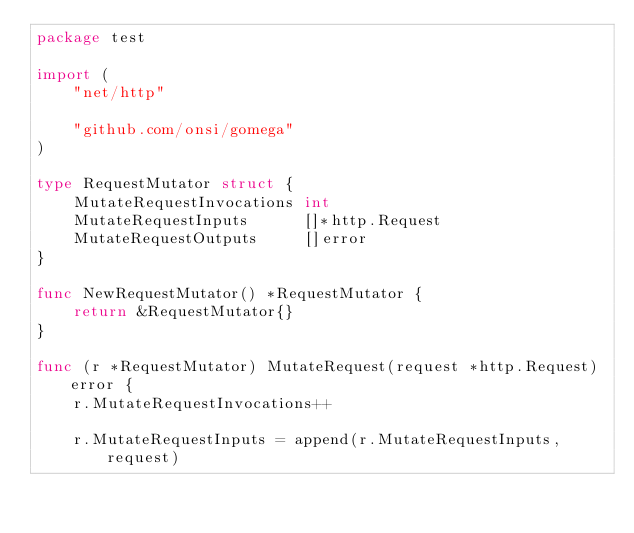<code> <loc_0><loc_0><loc_500><loc_500><_Go_>package test

import (
	"net/http"

	"github.com/onsi/gomega"
)

type RequestMutator struct {
	MutateRequestInvocations int
	MutateRequestInputs      []*http.Request
	MutateRequestOutputs     []error
}

func NewRequestMutator() *RequestMutator {
	return &RequestMutator{}
}

func (r *RequestMutator) MutateRequest(request *http.Request) error {
	r.MutateRequestInvocations++

	r.MutateRequestInputs = append(r.MutateRequestInputs, request)
</code> 